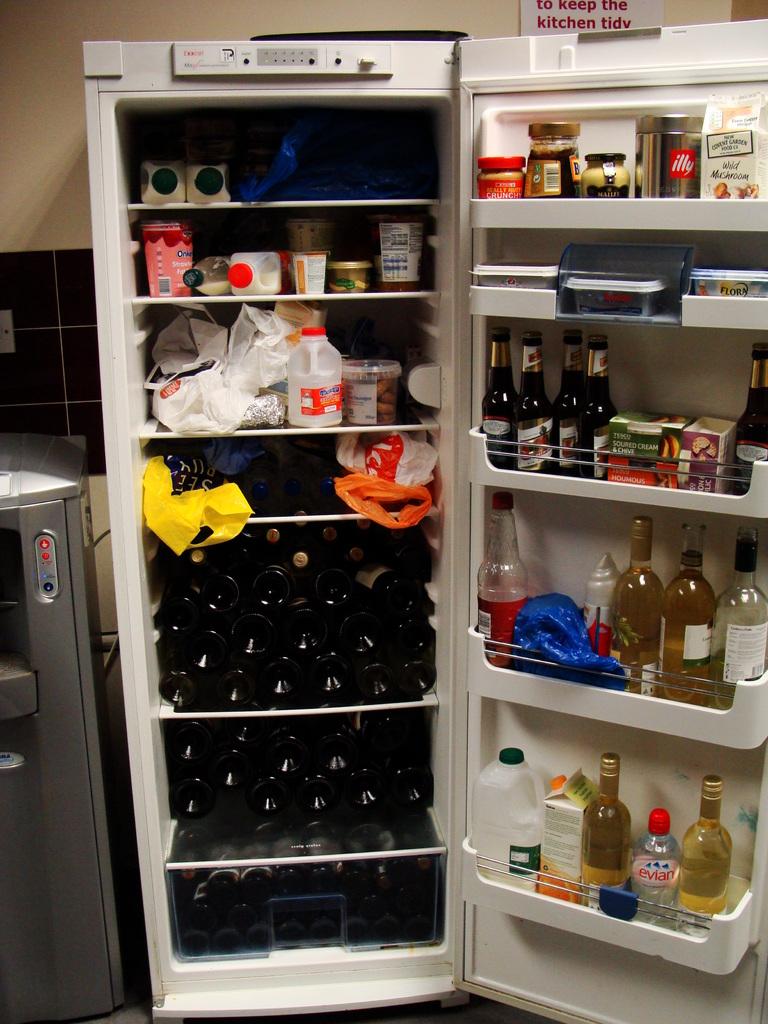What's the brand name of the water bottle on the lowest shelf?
Make the answer very short. Evian. What type of peanut butter is in the top of the door?
Your response must be concise. Crunchy. 